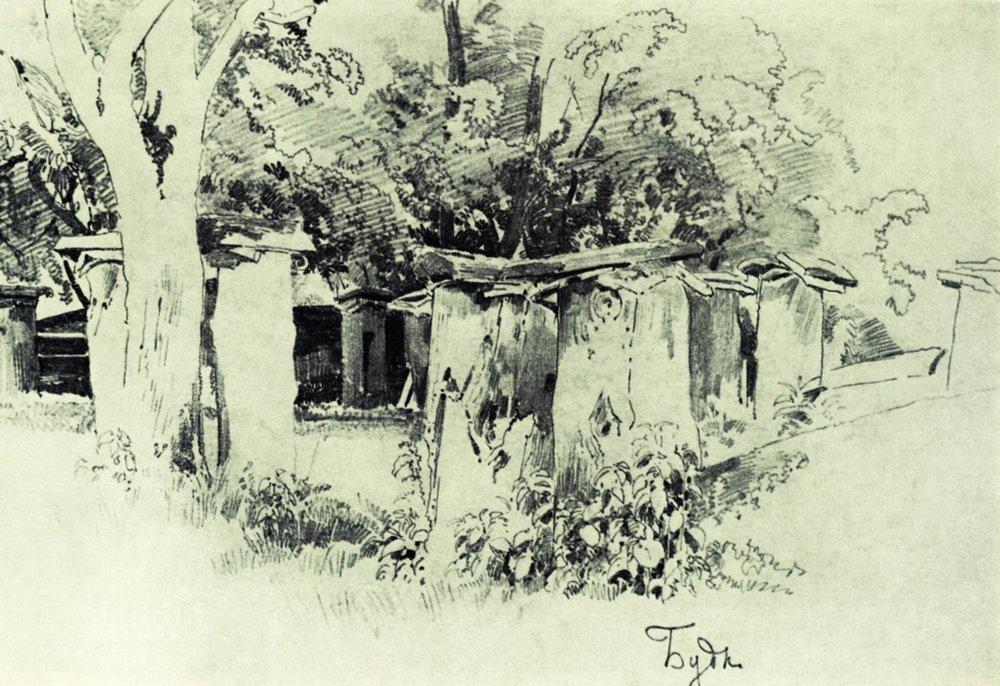What do you see happening in this image? The image is a striking black and white impressionistic sketch depicting a serene, rural landscape. To the left, a group of robust trees stretches toward the sky, their intricate branches forming a dynamic interplay of light and shadow, suggesting a breezy day. On the right, quaint houses with thatched roofs are tucked amidst dense foliage, evoking a sense of peaceful, rustic living. The artist, signed as "Tojin" in the corner, masterfully uses contrast and minimalistic strokes to emphasize the tranquility and simplicity of rural life, inviting the viewer into a timeless pastoral world. 